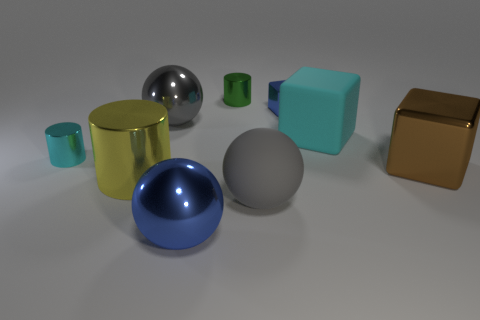Subtract 1 cylinders. How many cylinders are left? 2 Subtract all cylinders. How many objects are left? 6 Subtract all yellow objects. Subtract all tiny things. How many objects are left? 5 Add 8 cyan matte things. How many cyan matte things are left? 9 Add 9 large brown cubes. How many large brown cubes exist? 10 Subtract 0 red cylinders. How many objects are left? 9 